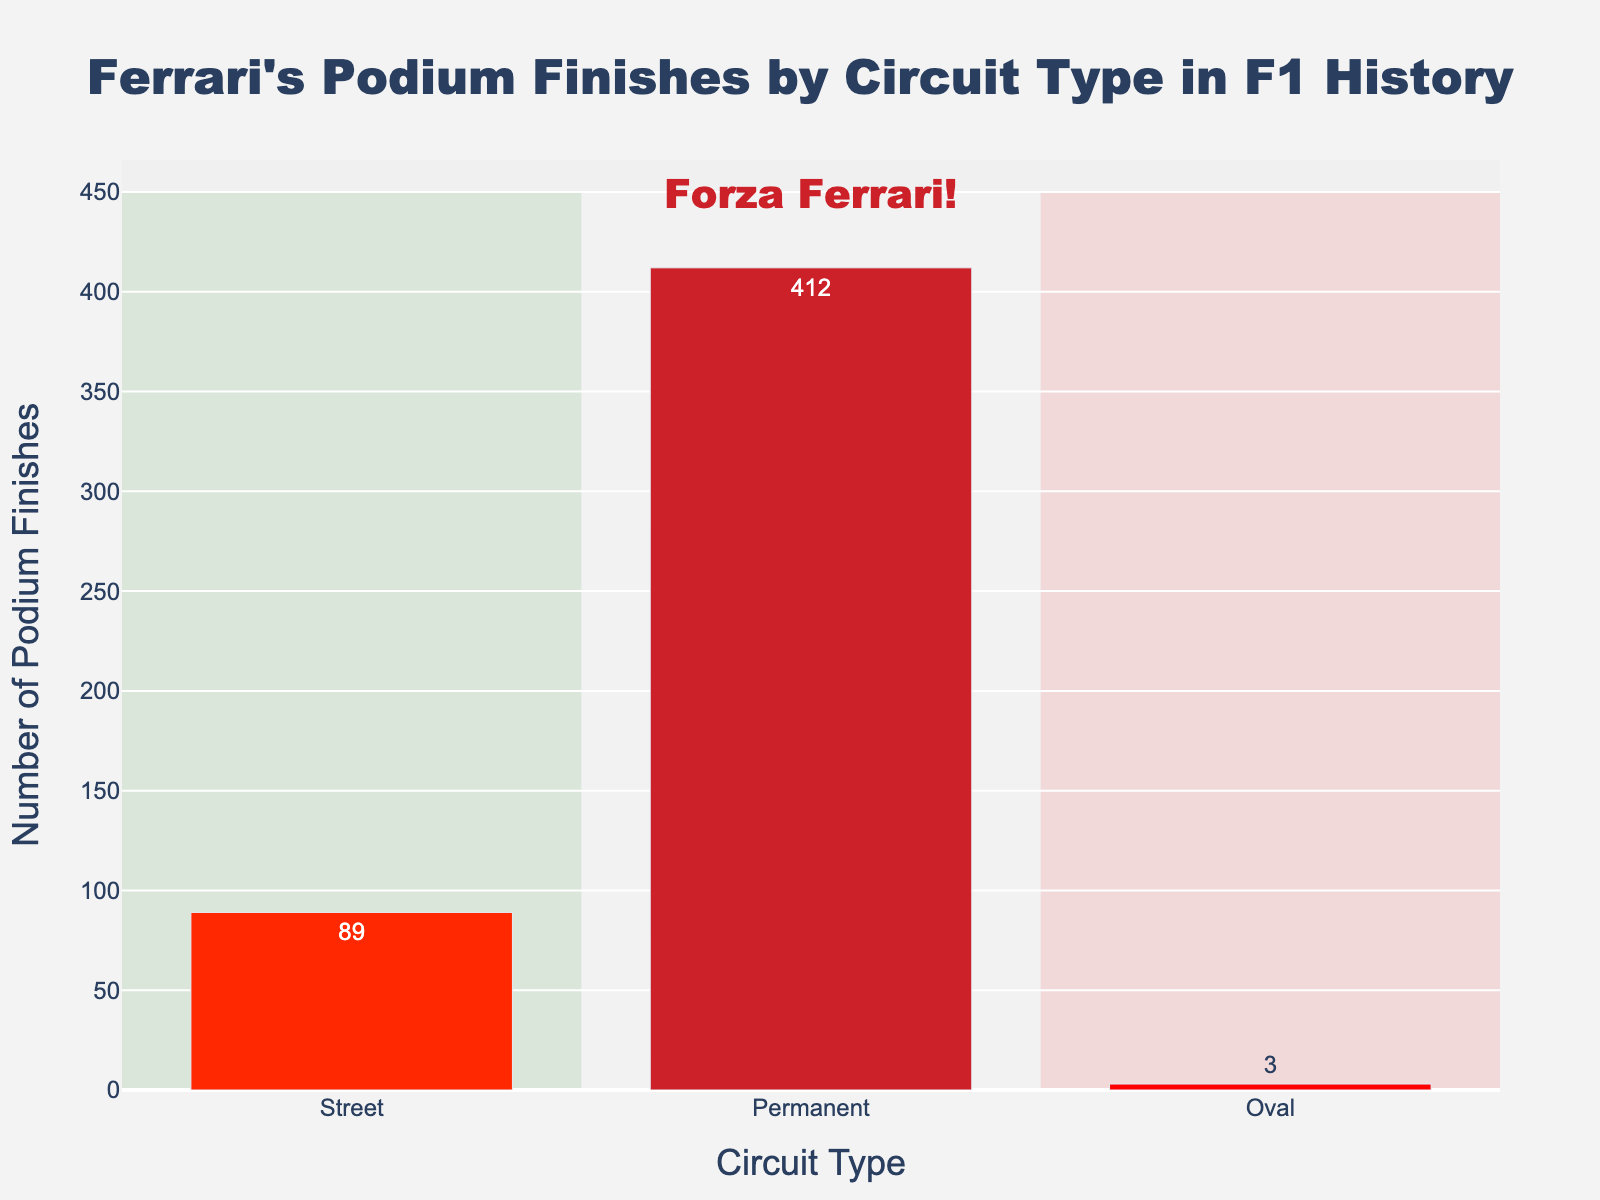What is the title of the histogram? The title of the histogram is placed at the top of the figure. It reads, "Ferrari's Podium Finishes by Circuit Type in F1 History."
Answer: Ferrari's Podium Finishes by Circuit Type in F1 History How many podium finishes did Ferrari achieve on street circuits? Look at the bar representing street circuits, it shows a value of 89.
Answer: 89 What are the three types of circuits represented in the histogram? The x-axis of the histogram categorizes the data into three circuit types: Street, Permanent, and Oval.
Answer: Street, Permanent, Oval How many more podium finishes did Ferrari have on permanent circuits compared to street circuits? Subtract the number of podium finishes on street circuits (89) from the number on permanent circuits (412). 412 - 89 = 323.
Answer: 323 Which circuit type had the fewest podium finishes for Ferrari? The y-axis shows that the bar for the Oval circuit type is the lowest with only 3 podium finishes.
Answer: Oval What's the total number of podium finishes shown in the histogram? Add the number of podium finishes for street (89), permanent (412), and oval (3) circuits. 89 + 412 + 3 = 504.
Answer: 504 How does the color scheme of the bars relate to Ferrari? The bars are colored in different shades of red, which are representative of Ferrari's traditional color.
Answer: Different shades of red What does the annotation at the top of the figure say? The annotation text is placed at the top of the figure and reads, "Forza Ferrari!"
Answer: Forza Ferrari! Are there more podium finishes on permanent circuits than the sum of street and oval circuits combined? Add the number of podium finishes on street (89) and oval (3) circuits: 89 + 3 = 92. Compare this sum (92) to the number on permanent circuits (412). Since 412 is greater than 92, permanent circuits have more podium finishes.
Answer: Yes What is the average number of podium finishes per circuit type? Calculate the average by dividing the total number of podium finishes (504) by the number of circuit types (3). 504 / 3 = 168.
Answer: 168 